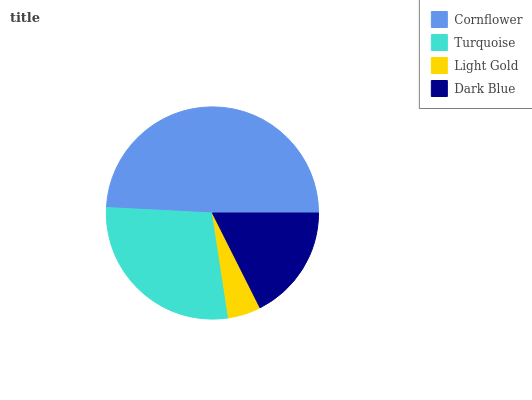Is Light Gold the minimum?
Answer yes or no. Yes. Is Cornflower the maximum?
Answer yes or no. Yes. Is Turquoise the minimum?
Answer yes or no. No. Is Turquoise the maximum?
Answer yes or no. No. Is Cornflower greater than Turquoise?
Answer yes or no. Yes. Is Turquoise less than Cornflower?
Answer yes or no. Yes. Is Turquoise greater than Cornflower?
Answer yes or no. No. Is Cornflower less than Turquoise?
Answer yes or no. No. Is Turquoise the high median?
Answer yes or no. Yes. Is Dark Blue the low median?
Answer yes or no. Yes. Is Dark Blue the high median?
Answer yes or no. No. Is Cornflower the low median?
Answer yes or no. No. 